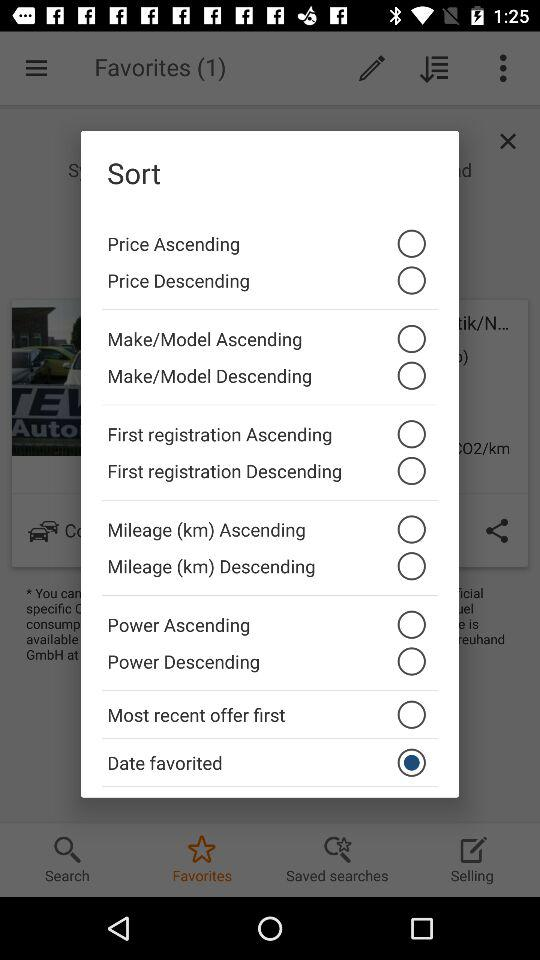Is "Price Ascending" selected or not? "Price Ascending" is not selected. 